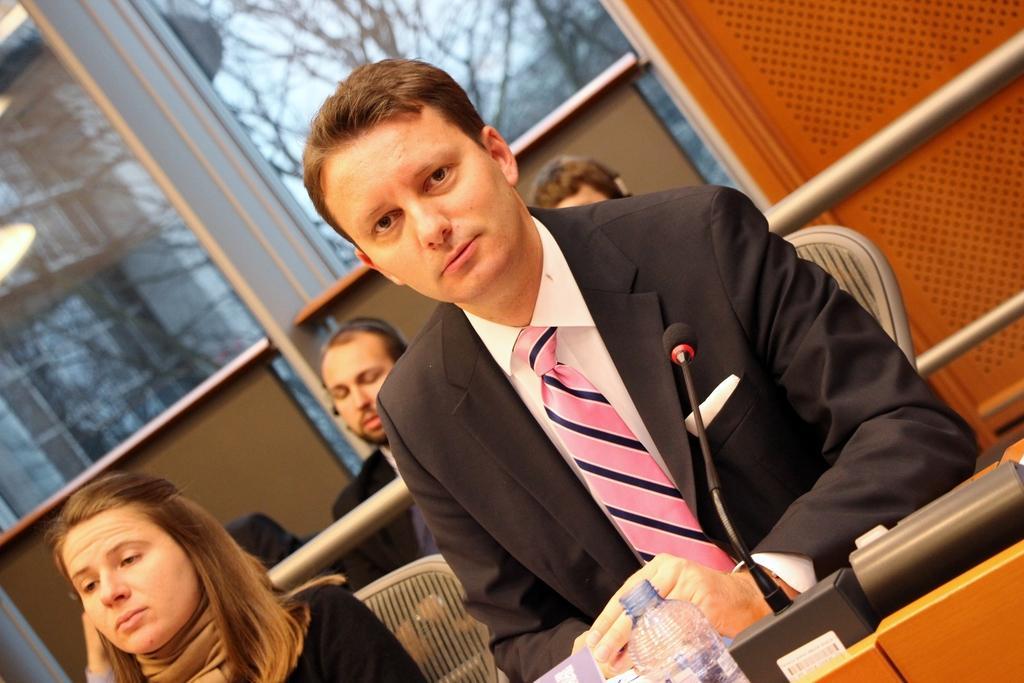Can you describe this image briefly? This is the picture of some people sitting in a room and one among them is sitting and there is a table in front of him and we can see a mic, water bottle on the table and also some other objects. In the background, we can see some trees and a building. 